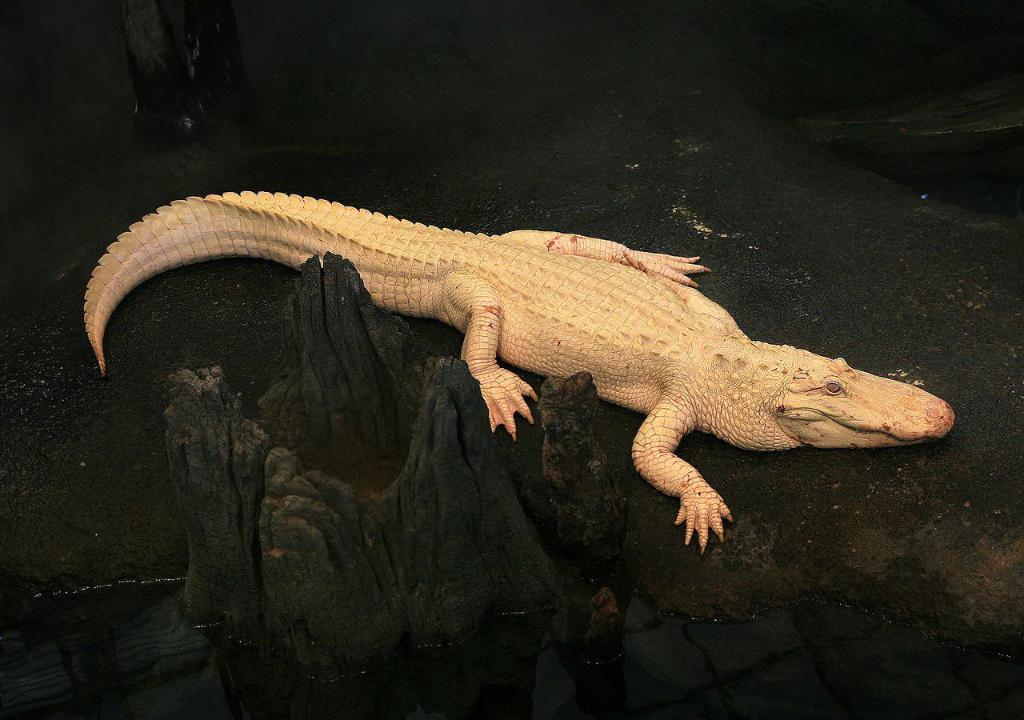Please provide a concise description of this image. In this image, we can see a crocodile on the ground, there is a black color tree trunk and we can see water. 